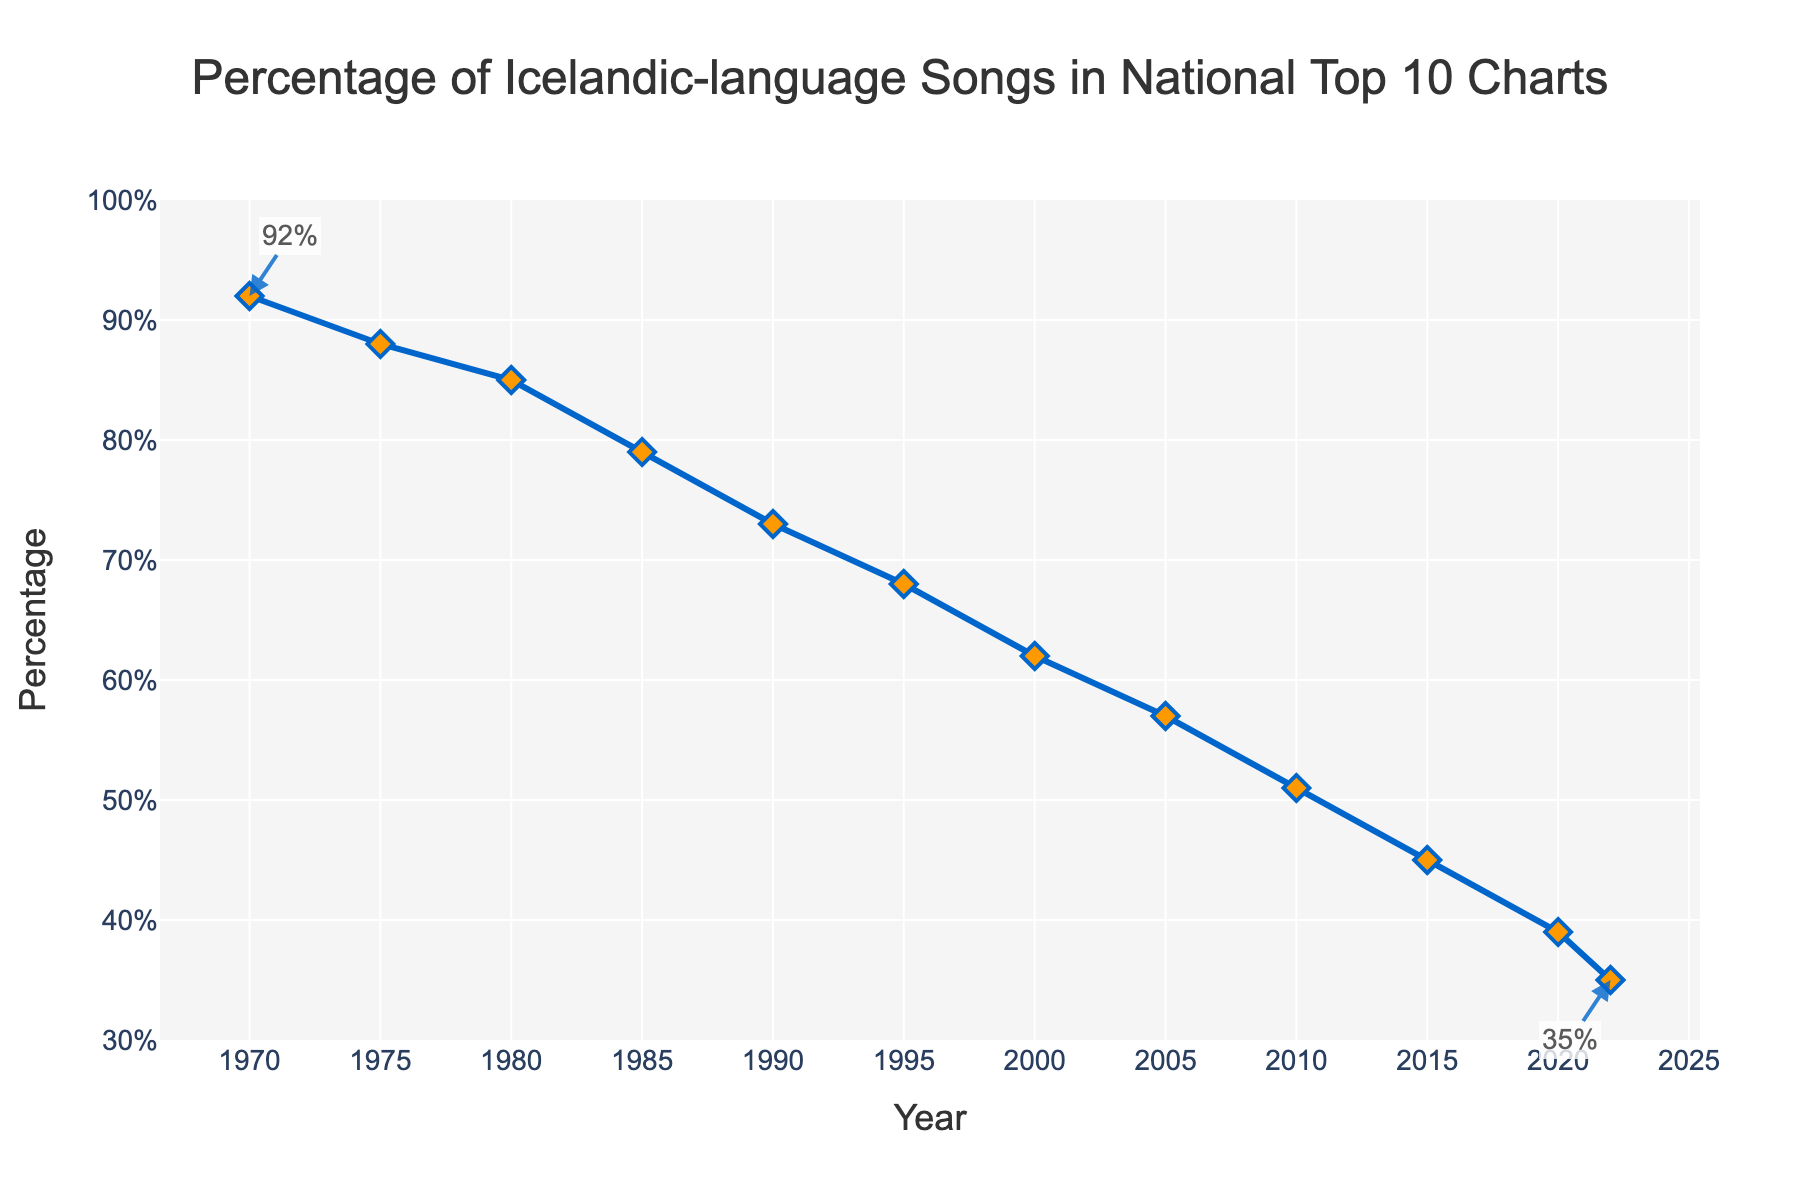what is the percentage decrease in Icelandic-language songs from 1970 to 2022? To find the percentage decrease, subtract the percentage in 2022 from the percentage in 1970 and then divide by the percentage in 1970. (92% - 35%) / 92% = 57 / 92 ≈ 0.6196 or roughly 61.96% decrease
Answer: ~61.96% which year had the lowest percentage of Icelandic-language songs in the top 10 charts? The chart shows that the lowest percentage of Icelandic-language songs is in 2022 with a value of 35%.
Answer: 2022 how many years did it take for the percentage of Icelandic-language songs to drop from above 80% to below 60%? The percentage drops from above 80% in 1980 (85%) to below 60% in 2005 (57%), taking a span of 2005 - 1980 = 25 years.
Answer: 25 during which years was there the largest drop in the percentage of Icelandic-language songs in the top 10 charts? To determine this, look for the largest difference between subsequent data points. The largest drop occurred from 1970 (92%) to 1975 (88%), which is a drop of 4%.
Answer: 1970 to 1975 what is the average percentage of Icelandic-language songs in the national charts across all recorded years? Sum all the percentage values and divide by the number of years. (92+88+85+79+73+68+62+57+51+45+39+35) / 12 = 774 / 12 = 64.5%
Answer: 64.5% which decade saw the steepest decline in the percentage of Icelandic-language songs? Compare the percentage decrease for each decade: 1970s (92% - 88% = 4%), 1980s (85% - 79% = 6%), 1990s (79% - 68% = 11%), 2000s (68% - 57% = 11%), 2010s (57% - 45% = 12%). The 2010s had the steepest decline with 12%.
Answer: 2010s is there any period where the percentage of Icelandic-language songs remained constant or increased? By observing the line plot, we can see that there is no period where the percentage remained constant or increased. The percentage consistently declines over time.
Answer: No what is the difference in the percentage of Icelandic-language songs between 1990 and 2000? Subtract the percentage in 2000 from the percentage in 1990. 73% - 62% = 11%.
Answer: 11% how much did the percentage decline on average per decade from 1970 to 2020? For each decade, calculate the difference and then take the average: (92-88) + (88-85) + (85-79) + (79-73) + (73-68) + (68-62) + (62-57) + (57-51) + (51-45) + (45-39) = 4 + 3 + 6 + 6 + 5 + 6 + 5 + 6 + 6 = 47 / 5 ≈ 9.4% per decade.
Answer: ~9.4% how does the trend of Icelandic-language songs percentage change across the years presented in the figure? The trend shows a steady decline in the percentage of Icelandic-language songs in the national top 10 charts from 1970 to 2022, dropping from 92% to 35%.
Answer: Steady decline 